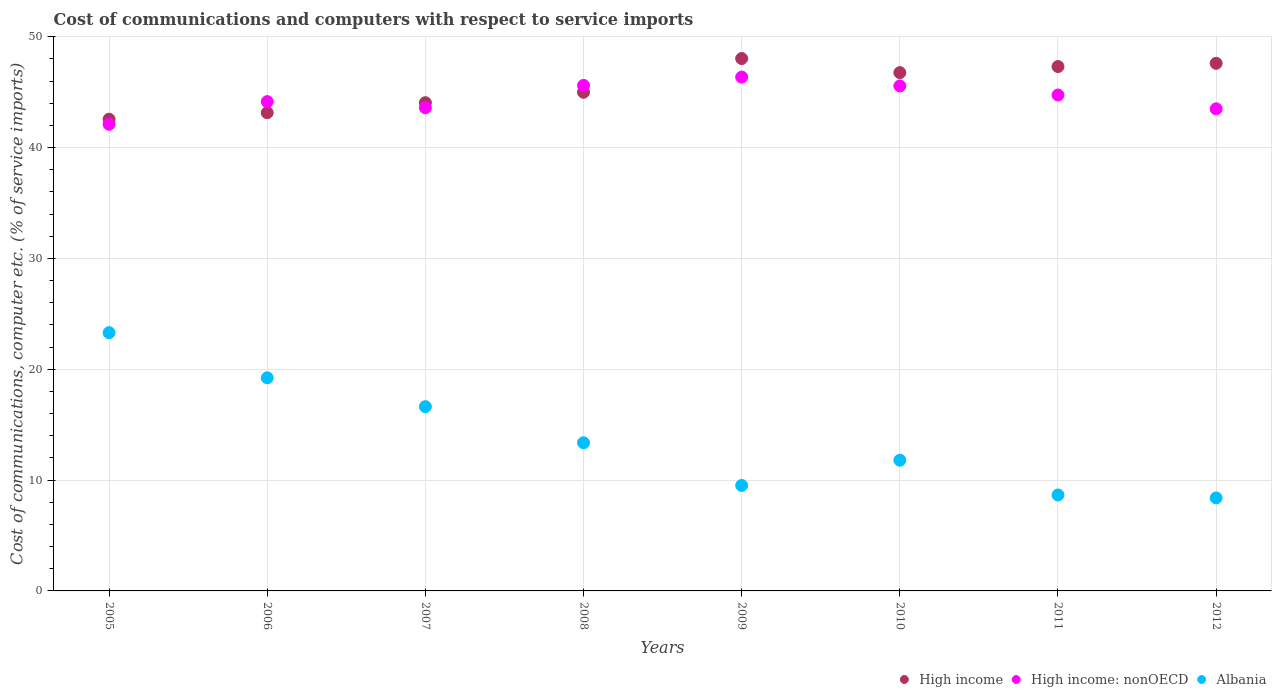What is the cost of communications and computers in High income in 2007?
Ensure brevity in your answer.  44.04. Across all years, what is the maximum cost of communications and computers in High income: nonOECD?
Provide a succinct answer. 46.35. Across all years, what is the minimum cost of communications and computers in Albania?
Your answer should be compact. 8.39. In which year was the cost of communications and computers in Albania maximum?
Make the answer very short. 2005. What is the total cost of communications and computers in High income: nonOECD in the graph?
Provide a succinct answer. 355.57. What is the difference between the cost of communications and computers in High income: nonOECD in 2011 and that in 2012?
Your response must be concise. 1.25. What is the difference between the cost of communications and computers in High income: nonOECD in 2005 and the cost of communications and computers in High income in 2008?
Your response must be concise. -2.89. What is the average cost of communications and computers in High income per year?
Provide a short and direct response. 45.55. In the year 2009, what is the difference between the cost of communications and computers in Albania and cost of communications and computers in High income?
Your answer should be very brief. -38.51. In how many years, is the cost of communications and computers in High income greater than 14 %?
Your response must be concise. 8. What is the ratio of the cost of communications and computers in Albania in 2006 to that in 2010?
Ensure brevity in your answer.  1.63. Is the difference between the cost of communications and computers in Albania in 2005 and 2008 greater than the difference between the cost of communications and computers in High income in 2005 and 2008?
Provide a succinct answer. Yes. What is the difference between the highest and the second highest cost of communications and computers in High income: nonOECD?
Offer a terse response. 0.75. What is the difference between the highest and the lowest cost of communications and computers in High income?
Your response must be concise. 5.47. How many years are there in the graph?
Keep it short and to the point. 8. What is the difference between two consecutive major ticks on the Y-axis?
Provide a succinct answer. 10. Are the values on the major ticks of Y-axis written in scientific E-notation?
Offer a very short reply. No. Where does the legend appear in the graph?
Your response must be concise. Bottom right. How many legend labels are there?
Offer a terse response. 3. What is the title of the graph?
Offer a very short reply. Cost of communications and computers with respect to service imports. What is the label or title of the X-axis?
Provide a succinct answer. Years. What is the label or title of the Y-axis?
Provide a short and direct response. Cost of communications, computer etc. (% of service imports). What is the Cost of communications, computer etc. (% of service imports) in High income in 2005?
Keep it short and to the point. 42.55. What is the Cost of communications, computer etc. (% of service imports) of High income: nonOECD in 2005?
Your answer should be compact. 42.1. What is the Cost of communications, computer etc. (% of service imports) in Albania in 2005?
Your response must be concise. 23.3. What is the Cost of communications, computer etc. (% of service imports) of High income in 2006?
Keep it short and to the point. 43.14. What is the Cost of communications, computer etc. (% of service imports) in High income: nonOECD in 2006?
Give a very brief answer. 44.14. What is the Cost of communications, computer etc. (% of service imports) in Albania in 2006?
Give a very brief answer. 19.23. What is the Cost of communications, computer etc. (% of service imports) in High income in 2007?
Keep it short and to the point. 44.04. What is the Cost of communications, computer etc. (% of service imports) of High income: nonOECD in 2007?
Your answer should be compact. 43.59. What is the Cost of communications, computer etc. (% of service imports) in Albania in 2007?
Make the answer very short. 16.62. What is the Cost of communications, computer etc. (% of service imports) of High income in 2008?
Your answer should be very brief. 44.98. What is the Cost of communications, computer etc. (% of service imports) in High income: nonOECD in 2008?
Ensure brevity in your answer.  45.61. What is the Cost of communications, computer etc. (% of service imports) in Albania in 2008?
Keep it short and to the point. 13.37. What is the Cost of communications, computer etc. (% of service imports) in High income in 2009?
Ensure brevity in your answer.  48.03. What is the Cost of communications, computer etc. (% of service imports) of High income: nonOECD in 2009?
Your answer should be very brief. 46.35. What is the Cost of communications, computer etc. (% of service imports) of Albania in 2009?
Your response must be concise. 9.52. What is the Cost of communications, computer etc. (% of service imports) in High income in 2010?
Your answer should be very brief. 46.76. What is the Cost of communications, computer etc. (% of service imports) in High income: nonOECD in 2010?
Your response must be concise. 45.55. What is the Cost of communications, computer etc. (% of service imports) of Albania in 2010?
Provide a succinct answer. 11.79. What is the Cost of communications, computer etc. (% of service imports) in High income in 2011?
Keep it short and to the point. 47.3. What is the Cost of communications, computer etc. (% of service imports) of High income: nonOECD in 2011?
Provide a short and direct response. 44.74. What is the Cost of communications, computer etc. (% of service imports) of Albania in 2011?
Offer a very short reply. 8.65. What is the Cost of communications, computer etc. (% of service imports) of High income in 2012?
Ensure brevity in your answer.  47.59. What is the Cost of communications, computer etc. (% of service imports) of High income: nonOECD in 2012?
Give a very brief answer. 43.49. What is the Cost of communications, computer etc. (% of service imports) in Albania in 2012?
Provide a succinct answer. 8.39. Across all years, what is the maximum Cost of communications, computer etc. (% of service imports) of High income?
Your response must be concise. 48.03. Across all years, what is the maximum Cost of communications, computer etc. (% of service imports) of High income: nonOECD?
Make the answer very short. 46.35. Across all years, what is the maximum Cost of communications, computer etc. (% of service imports) of Albania?
Provide a succinct answer. 23.3. Across all years, what is the minimum Cost of communications, computer etc. (% of service imports) of High income?
Provide a succinct answer. 42.55. Across all years, what is the minimum Cost of communications, computer etc. (% of service imports) in High income: nonOECD?
Your response must be concise. 42.1. Across all years, what is the minimum Cost of communications, computer etc. (% of service imports) of Albania?
Your response must be concise. 8.39. What is the total Cost of communications, computer etc. (% of service imports) in High income in the graph?
Offer a terse response. 364.4. What is the total Cost of communications, computer etc. (% of service imports) in High income: nonOECD in the graph?
Your answer should be compact. 355.57. What is the total Cost of communications, computer etc. (% of service imports) in Albania in the graph?
Provide a short and direct response. 110.87. What is the difference between the Cost of communications, computer etc. (% of service imports) in High income in 2005 and that in 2006?
Your response must be concise. -0.59. What is the difference between the Cost of communications, computer etc. (% of service imports) in High income: nonOECD in 2005 and that in 2006?
Provide a succinct answer. -2.04. What is the difference between the Cost of communications, computer etc. (% of service imports) of Albania in 2005 and that in 2006?
Provide a short and direct response. 4.07. What is the difference between the Cost of communications, computer etc. (% of service imports) in High income in 2005 and that in 2007?
Give a very brief answer. -1.49. What is the difference between the Cost of communications, computer etc. (% of service imports) in High income: nonOECD in 2005 and that in 2007?
Your answer should be compact. -1.49. What is the difference between the Cost of communications, computer etc. (% of service imports) of Albania in 2005 and that in 2007?
Offer a very short reply. 6.67. What is the difference between the Cost of communications, computer etc. (% of service imports) of High income in 2005 and that in 2008?
Ensure brevity in your answer.  -2.43. What is the difference between the Cost of communications, computer etc. (% of service imports) of High income: nonOECD in 2005 and that in 2008?
Your response must be concise. -3.51. What is the difference between the Cost of communications, computer etc. (% of service imports) in Albania in 2005 and that in 2008?
Keep it short and to the point. 9.93. What is the difference between the Cost of communications, computer etc. (% of service imports) of High income in 2005 and that in 2009?
Your response must be concise. -5.47. What is the difference between the Cost of communications, computer etc. (% of service imports) in High income: nonOECD in 2005 and that in 2009?
Your answer should be very brief. -4.26. What is the difference between the Cost of communications, computer etc. (% of service imports) in Albania in 2005 and that in 2009?
Your answer should be very brief. 13.78. What is the difference between the Cost of communications, computer etc. (% of service imports) in High income in 2005 and that in 2010?
Make the answer very short. -4.2. What is the difference between the Cost of communications, computer etc. (% of service imports) in High income: nonOECD in 2005 and that in 2010?
Give a very brief answer. -3.46. What is the difference between the Cost of communications, computer etc. (% of service imports) in Albania in 2005 and that in 2010?
Ensure brevity in your answer.  11.51. What is the difference between the Cost of communications, computer etc. (% of service imports) of High income in 2005 and that in 2011?
Your answer should be compact. -4.75. What is the difference between the Cost of communications, computer etc. (% of service imports) of High income: nonOECD in 2005 and that in 2011?
Your response must be concise. -2.64. What is the difference between the Cost of communications, computer etc. (% of service imports) of Albania in 2005 and that in 2011?
Provide a short and direct response. 14.64. What is the difference between the Cost of communications, computer etc. (% of service imports) of High income in 2005 and that in 2012?
Provide a short and direct response. -5.04. What is the difference between the Cost of communications, computer etc. (% of service imports) in High income: nonOECD in 2005 and that in 2012?
Your answer should be compact. -1.4. What is the difference between the Cost of communications, computer etc. (% of service imports) in Albania in 2005 and that in 2012?
Keep it short and to the point. 14.91. What is the difference between the Cost of communications, computer etc. (% of service imports) of High income in 2006 and that in 2007?
Your response must be concise. -0.9. What is the difference between the Cost of communications, computer etc. (% of service imports) of High income: nonOECD in 2006 and that in 2007?
Provide a short and direct response. 0.55. What is the difference between the Cost of communications, computer etc. (% of service imports) in Albania in 2006 and that in 2007?
Make the answer very short. 2.6. What is the difference between the Cost of communications, computer etc. (% of service imports) of High income in 2006 and that in 2008?
Ensure brevity in your answer.  -1.84. What is the difference between the Cost of communications, computer etc. (% of service imports) in High income: nonOECD in 2006 and that in 2008?
Provide a short and direct response. -1.47. What is the difference between the Cost of communications, computer etc. (% of service imports) in Albania in 2006 and that in 2008?
Make the answer very short. 5.86. What is the difference between the Cost of communications, computer etc. (% of service imports) of High income in 2006 and that in 2009?
Give a very brief answer. -4.89. What is the difference between the Cost of communications, computer etc. (% of service imports) in High income: nonOECD in 2006 and that in 2009?
Offer a terse response. -2.21. What is the difference between the Cost of communications, computer etc. (% of service imports) in Albania in 2006 and that in 2009?
Provide a short and direct response. 9.71. What is the difference between the Cost of communications, computer etc. (% of service imports) in High income in 2006 and that in 2010?
Keep it short and to the point. -3.62. What is the difference between the Cost of communications, computer etc. (% of service imports) of High income: nonOECD in 2006 and that in 2010?
Make the answer very short. -1.41. What is the difference between the Cost of communications, computer etc. (% of service imports) in Albania in 2006 and that in 2010?
Your response must be concise. 7.44. What is the difference between the Cost of communications, computer etc. (% of service imports) in High income in 2006 and that in 2011?
Your answer should be very brief. -4.16. What is the difference between the Cost of communications, computer etc. (% of service imports) in High income: nonOECD in 2006 and that in 2011?
Offer a very short reply. -0.6. What is the difference between the Cost of communications, computer etc. (% of service imports) in Albania in 2006 and that in 2011?
Ensure brevity in your answer.  10.57. What is the difference between the Cost of communications, computer etc. (% of service imports) of High income in 2006 and that in 2012?
Keep it short and to the point. -4.45. What is the difference between the Cost of communications, computer etc. (% of service imports) in High income: nonOECD in 2006 and that in 2012?
Give a very brief answer. 0.65. What is the difference between the Cost of communications, computer etc. (% of service imports) in Albania in 2006 and that in 2012?
Offer a terse response. 10.84. What is the difference between the Cost of communications, computer etc. (% of service imports) in High income in 2007 and that in 2008?
Provide a succinct answer. -0.94. What is the difference between the Cost of communications, computer etc. (% of service imports) of High income: nonOECD in 2007 and that in 2008?
Give a very brief answer. -2.02. What is the difference between the Cost of communications, computer etc. (% of service imports) of Albania in 2007 and that in 2008?
Provide a short and direct response. 3.26. What is the difference between the Cost of communications, computer etc. (% of service imports) of High income in 2007 and that in 2009?
Provide a succinct answer. -3.98. What is the difference between the Cost of communications, computer etc. (% of service imports) of High income: nonOECD in 2007 and that in 2009?
Give a very brief answer. -2.77. What is the difference between the Cost of communications, computer etc. (% of service imports) of Albania in 2007 and that in 2009?
Make the answer very short. 7.11. What is the difference between the Cost of communications, computer etc. (% of service imports) of High income in 2007 and that in 2010?
Offer a terse response. -2.71. What is the difference between the Cost of communications, computer etc. (% of service imports) of High income: nonOECD in 2007 and that in 2010?
Give a very brief answer. -1.97. What is the difference between the Cost of communications, computer etc. (% of service imports) of Albania in 2007 and that in 2010?
Keep it short and to the point. 4.84. What is the difference between the Cost of communications, computer etc. (% of service imports) of High income in 2007 and that in 2011?
Give a very brief answer. -3.26. What is the difference between the Cost of communications, computer etc. (% of service imports) of High income: nonOECD in 2007 and that in 2011?
Make the answer very short. -1.15. What is the difference between the Cost of communications, computer etc. (% of service imports) of Albania in 2007 and that in 2011?
Provide a succinct answer. 7.97. What is the difference between the Cost of communications, computer etc. (% of service imports) in High income in 2007 and that in 2012?
Ensure brevity in your answer.  -3.55. What is the difference between the Cost of communications, computer etc. (% of service imports) of High income: nonOECD in 2007 and that in 2012?
Make the answer very short. 0.09. What is the difference between the Cost of communications, computer etc. (% of service imports) of Albania in 2007 and that in 2012?
Make the answer very short. 8.23. What is the difference between the Cost of communications, computer etc. (% of service imports) in High income in 2008 and that in 2009?
Offer a very short reply. -3.04. What is the difference between the Cost of communications, computer etc. (% of service imports) of High income: nonOECD in 2008 and that in 2009?
Offer a very short reply. -0.75. What is the difference between the Cost of communications, computer etc. (% of service imports) of Albania in 2008 and that in 2009?
Your answer should be compact. 3.85. What is the difference between the Cost of communications, computer etc. (% of service imports) in High income in 2008 and that in 2010?
Keep it short and to the point. -1.77. What is the difference between the Cost of communications, computer etc. (% of service imports) in High income: nonOECD in 2008 and that in 2010?
Offer a very short reply. 0.05. What is the difference between the Cost of communications, computer etc. (% of service imports) of Albania in 2008 and that in 2010?
Your answer should be very brief. 1.58. What is the difference between the Cost of communications, computer etc. (% of service imports) of High income in 2008 and that in 2011?
Your response must be concise. -2.32. What is the difference between the Cost of communications, computer etc. (% of service imports) of High income: nonOECD in 2008 and that in 2011?
Provide a short and direct response. 0.87. What is the difference between the Cost of communications, computer etc. (% of service imports) of Albania in 2008 and that in 2011?
Give a very brief answer. 4.71. What is the difference between the Cost of communications, computer etc. (% of service imports) of High income in 2008 and that in 2012?
Give a very brief answer. -2.61. What is the difference between the Cost of communications, computer etc. (% of service imports) of High income: nonOECD in 2008 and that in 2012?
Your response must be concise. 2.11. What is the difference between the Cost of communications, computer etc. (% of service imports) in Albania in 2008 and that in 2012?
Your response must be concise. 4.97. What is the difference between the Cost of communications, computer etc. (% of service imports) in High income in 2009 and that in 2010?
Give a very brief answer. 1.27. What is the difference between the Cost of communications, computer etc. (% of service imports) of High income: nonOECD in 2009 and that in 2010?
Give a very brief answer. 0.8. What is the difference between the Cost of communications, computer etc. (% of service imports) in Albania in 2009 and that in 2010?
Offer a very short reply. -2.27. What is the difference between the Cost of communications, computer etc. (% of service imports) in High income in 2009 and that in 2011?
Give a very brief answer. 0.72. What is the difference between the Cost of communications, computer etc. (% of service imports) of High income: nonOECD in 2009 and that in 2011?
Give a very brief answer. 1.62. What is the difference between the Cost of communications, computer etc. (% of service imports) in Albania in 2009 and that in 2011?
Give a very brief answer. 0.86. What is the difference between the Cost of communications, computer etc. (% of service imports) in High income in 2009 and that in 2012?
Offer a very short reply. 0.43. What is the difference between the Cost of communications, computer etc. (% of service imports) in High income: nonOECD in 2009 and that in 2012?
Make the answer very short. 2.86. What is the difference between the Cost of communications, computer etc. (% of service imports) in Albania in 2009 and that in 2012?
Your answer should be compact. 1.12. What is the difference between the Cost of communications, computer etc. (% of service imports) in High income in 2010 and that in 2011?
Offer a very short reply. -0.55. What is the difference between the Cost of communications, computer etc. (% of service imports) in High income: nonOECD in 2010 and that in 2011?
Offer a terse response. 0.82. What is the difference between the Cost of communications, computer etc. (% of service imports) of Albania in 2010 and that in 2011?
Provide a succinct answer. 3.13. What is the difference between the Cost of communications, computer etc. (% of service imports) of High income in 2010 and that in 2012?
Ensure brevity in your answer.  -0.84. What is the difference between the Cost of communications, computer etc. (% of service imports) in High income: nonOECD in 2010 and that in 2012?
Your response must be concise. 2.06. What is the difference between the Cost of communications, computer etc. (% of service imports) in Albania in 2010 and that in 2012?
Give a very brief answer. 3.4. What is the difference between the Cost of communications, computer etc. (% of service imports) of High income in 2011 and that in 2012?
Keep it short and to the point. -0.29. What is the difference between the Cost of communications, computer etc. (% of service imports) of High income: nonOECD in 2011 and that in 2012?
Ensure brevity in your answer.  1.25. What is the difference between the Cost of communications, computer etc. (% of service imports) in Albania in 2011 and that in 2012?
Keep it short and to the point. 0.26. What is the difference between the Cost of communications, computer etc. (% of service imports) of High income in 2005 and the Cost of communications, computer etc. (% of service imports) of High income: nonOECD in 2006?
Provide a short and direct response. -1.59. What is the difference between the Cost of communications, computer etc. (% of service imports) in High income in 2005 and the Cost of communications, computer etc. (% of service imports) in Albania in 2006?
Make the answer very short. 23.33. What is the difference between the Cost of communications, computer etc. (% of service imports) in High income: nonOECD in 2005 and the Cost of communications, computer etc. (% of service imports) in Albania in 2006?
Your answer should be very brief. 22.87. What is the difference between the Cost of communications, computer etc. (% of service imports) in High income in 2005 and the Cost of communications, computer etc. (% of service imports) in High income: nonOECD in 2007?
Keep it short and to the point. -1.03. What is the difference between the Cost of communications, computer etc. (% of service imports) in High income in 2005 and the Cost of communications, computer etc. (% of service imports) in Albania in 2007?
Keep it short and to the point. 25.93. What is the difference between the Cost of communications, computer etc. (% of service imports) of High income: nonOECD in 2005 and the Cost of communications, computer etc. (% of service imports) of Albania in 2007?
Offer a very short reply. 25.47. What is the difference between the Cost of communications, computer etc. (% of service imports) in High income in 2005 and the Cost of communications, computer etc. (% of service imports) in High income: nonOECD in 2008?
Offer a very short reply. -3.05. What is the difference between the Cost of communications, computer etc. (% of service imports) of High income in 2005 and the Cost of communications, computer etc. (% of service imports) of Albania in 2008?
Your response must be concise. 29.19. What is the difference between the Cost of communications, computer etc. (% of service imports) in High income: nonOECD in 2005 and the Cost of communications, computer etc. (% of service imports) in Albania in 2008?
Make the answer very short. 28.73. What is the difference between the Cost of communications, computer etc. (% of service imports) in High income in 2005 and the Cost of communications, computer etc. (% of service imports) in High income: nonOECD in 2009?
Offer a terse response. -3.8. What is the difference between the Cost of communications, computer etc. (% of service imports) in High income in 2005 and the Cost of communications, computer etc. (% of service imports) in Albania in 2009?
Your answer should be very brief. 33.04. What is the difference between the Cost of communications, computer etc. (% of service imports) in High income: nonOECD in 2005 and the Cost of communications, computer etc. (% of service imports) in Albania in 2009?
Your response must be concise. 32.58. What is the difference between the Cost of communications, computer etc. (% of service imports) of High income in 2005 and the Cost of communications, computer etc. (% of service imports) of High income: nonOECD in 2010?
Make the answer very short. -3. What is the difference between the Cost of communications, computer etc. (% of service imports) in High income in 2005 and the Cost of communications, computer etc. (% of service imports) in Albania in 2010?
Your response must be concise. 30.77. What is the difference between the Cost of communications, computer etc. (% of service imports) in High income: nonOECD in 2005 and the Cost of communications, computer etc. (% of service imports) in Albania in 2010?
Provide a succinct answer. 30.31. What is the difference between the Cost of communications, computer etc. (% of service imports) of High income in 2005 and the Cost of communications, computer etc. (% of service imports) of High income: nonOECD in 2011?
Make the answer very short. -2.18. What is the difference between the Cost of communications, computer etc. (% of service imports) in High income in 2005 and the Cost of communications, computer etc. (% of service imports) in Albania in 2011?
Provide a short and direct response. 33.9. What is the difference between the Cost of communications, computer etc. (% of service imports) in High income: nonOECD in 2005 and the Cost of communications, computer etc. (% of service imports) in Albania in 2011?
Ensure brevity in your answer.  33.44. What is the difference between the Cost of communications, computer etc. (% of service imports) in High income in 2005 and the Cost of communications, computer etc. (% of service imports) in High income: nonOECD in 2012?
Make the answer very short. -0.94. What is the difference between the Cost of communications, computer etc. (% of service imports) of High income in 2005 and the Cost of communications, computer etc. (% of service imports) of Albania in 2012?
Ensure brevity in your answer.  34.16. What is the difference between the Cost of communications, computer etc. (% of service imports) in High income: nonOECD in 2005 and the Cost of communications, computer etc. (% of service imports) in Albania in 2012?
Provide a succinct answer. 33.7. What is the difference between the Cost of communications, computer etc. (% of service imports) of High income in 2006 and the Cost of communications, computer etc. (% of service imports) of High income: nonOECD in 2007?
Provide a short and direct response. -0.45. What is the difference between the Cost of communications, computer etc. (% of service imports) in High income in 2006 and the Cost of communications, computer etc. (% of service imports) in Albania in 2007?
Your response must be concise. 26.52. What is the difference between the Cost of communications, computer etc. (% of service imports) of High income: nonOECD in 2006 and the Cost of communications, computer etc. (% of service imports) of Albania in 2007?
Make the answer very short. 27.52. What is the difference between the Cost of communications, computer etc. (% of service imports) in High income in 2006 and the Cost of communications, computer etc. (% of service imports) in High income: nonOECD in 2008?
Make the answer very short. -2.46. What is the difference between the Cost of communications, computer etc. (% of service imports) of High income in 2006 and the Cost of communications, computer etc. (% of service imports) of Albania in 2008?
Make the answer very short. 29.77. What is the difference between the Cost of communications, computer etc. (% of service imports) of High income: nonOECD in 2006 and the Cost of communications, computer etc. (% of service imports) of Albania in 2008?
Your answer should be very brief. 30.77. What is the difference between the Cost of communications, computer etc. (% of service imports) in High income in 2006 and the Cost of communications, computer etc. (% of service imports) in High income: nonOECD in 2009?
Offer a very short reply. -3.21. What is the difference between the Cost of communications, computer etc. (% of service imports) of High income in 2006 and the Cost of communications, computer etc. (% of service imports) of Albania in 2009?
Offer a terse response. 33.62. What is the difference between the Cost of communications, computer etc. (% of service imports) in High income: nonOECD in 2006 and the Cost of communications, computer etc. (% of service imports) in Albania in 2009?
Provide a succinct answer. 34.62. What is the difference between the Cost of communications, computer etc. (% of service imports) in High income in 2006 and the Cost of communications, computer etc. (% of service imports) in High income: nonOECD in 2010?
Provide a succinct answer. -2.41. What is the difference between the Cost of communications, computer etc. (% of service imports) of High income in 2006 and the Cost of communications, computer etc. (% of service imports) of Albania in 2010?
Make the answer very short. 31.35. What is the difference between the Cost of communications, computer etc. (% of service imports) in High income: nonOECD in 2006 and the Cost of communications, computer etc. (% of service imports) in Albania in 2010?
Provide a succinct answer. 32.35. What is the difference between the Cost of communications, computer etc. (% of service imports) of High income in 2006 and the Cost of communications, computer etc. (% of service imports) of High income: nonOECD in 2011?
Make the answer very short. -1.6. What is the difference between the Cost of communications, computer etc. (% of service imports) of High income in 2006 and the Cost of communications, computer etc. (% of service imports) of Albania in 2011?
Keep it short and to the point. 34.49. What is the difference between the Cost of communications, computer etc. (% of service imports) of High income: nonOECD in 2006 and the Cost of communications, computer etc. (% of service imports) of Albania in 2011?
Keep it short and to the point. 35.49. What is the difference between the Cost of communications, computer etc. (% of service imports) in High income in 2006 and the Cost of communications, computer etc. (% of service imports) in High income: nonOECD in 2012?
Ensure brevity in your answer.  -0.35. What is the difference between the Cost of communications, computer etc. (% of service imports) in High income in 2006 and the Cost of communications, computer etc. (% of service imports) in Albania in 2012?
Ensure brevity in your answer.  34.75. What is the difference between the Cost of communications, computer etc. (% of service imports) of High income: nonOECD in 2006 and the Cost of communications, computer etc. (% of service imports) of Albania in 2012?
Provide a short and direct response. 35.75. What is the difference between the Cost of communications, computer etc. (% of service imports) of High income in 2007 and the Cost of communications, computer etc. (% of service imports) of High income: nonOECD in 2008?
Give a very brief answer. -1.56. What is the difference between the Cost of communications, computer etc. (% of service imports) of High income in 2007 and the Cost of communications, computer etc. (% of service imports) of Albania in 2008?
Ensure brevity in your answer.  30.68. What is the difference between the Cost of communications, computer etc. (% of service imports) of High income: nonOECD in 2007 and the Cost of communications, computer etc. (% of service imports) of Albania in 2008?
Make the answer very short. 30.22. What is the difference between the Cost of communications, computer etc. (% of service imports) in High income in 2007 and the Cost of communications, computer etc. (% of service imports) in High income: nonOECD in 2009?
Offer a very short reply. -2.31. What is the difference between the Cost of communications, computer etc. (% of service imports) of High income in 2007 and the Cost of communications, computer etc. (% of service imports) of Albania in 2009?
Your response must be concise. 34.53. What is the difference between the Cost of communications, computer etc. (% of service imports) in High income: nonOECD in 2007 and the Cost of communications, computer etc. (% of service imports) in Albania in 2009?
Your answer should be very brief. 34.07. What is the difference between the Cost of communications, computer etc. (% of service imports) of High income in 2007 and the Cost of communications, computer etc. (% of service imports) of High income: nonOECD in 2010?
Make the answer very short. -1.51. What is the difference between the Cost of communications, computer etc. (% of service imports) in High income in 2007 and the Cost of communications, computer etc. (% of service imports) in Albania in 2010?
Your response must be concise. 32.25. What is the difference between the Cost of communications, computer etc. (% of service imports) of High income: nonOECD in 2007 and the Cost of communications, computer etc. (% of service imports) of Albania in 2010?
Provide a short and direct response. 31.8. What is the difference between the Cost of communications, computer etc. (% of service imports) of High income in 2007 and the Cost of communications, computer etc. (% of service imports) of High income: nonOECD in 2011?
Offer a terse response. -0.69. What is the difference between the Cost of communications, computer etc. (% of service imports) of High income in 2007 and the Cost of communications, computer etc. (% of service imports) of Albania in 2011?
Offer a very short reply. 35.39. What is the difference between the Cost of communications, computer etc. (% of service imports) of High income: nonOECD in 2007 and the Cost of communications, computer etc. (% of service imports) of Albania in 2011?
Offer a very short reply. 34.93. What is the difference between the Cost of communications, computer etc. (% of service imports) of High income in 2007 and the Cost of communications, computer etc. (% of service imports) of High income: nonOECD in 2012?
Give a very brief answer. 0.55. What is the difference between the Cost of communications, computer etc. (% of service imports) in High income in 2007 and the Cost of communications, computer etc. (% of service imports) in Albania in 2012?
Provide a short and direct response. 35.65. What is the difference between the Cost of communications, computer etc. (% of service imports) in High income: nonOECD in 2007 and the Cost of communications, computer etc. (% of service imports) in Albania in 2012?
Ensure brevity in your answer.  35.2. What is the difference between the Cost of communications, computer etc. (% of service imports) of High income in 2008 and the Cost of communications, computer etc. (% of service imports) of High income: nonOECD in 2009?
Provide a succinct answer. -1.37. What is the difference between the Cost of communications, computer etc. (% of service imports) in High income in 2008 and the Cost of communications, computer etc. (% of service imports) in Albania in 2009?
Offer a terse response. 35.47. What is the difference between the Cost of communications, computer etc. (% of service imports) of High income: nonOECD in 2008 and the Cost of communications, computer etc. (% of service imports) of Albania in 2009?
Give a very brief answer. 36.09. What is the difference between the Cost of communications, computer etc. (% of service imports) of High income in 2008 and the Cost of communications, computer etc. (% of service imports) of High income: nonOECD in 2010?
Provide a succinct answer. -0.57. What is the difference between the Cost of communications, computer etc. (% of service imports) in High income in 2008 and the Cost of communications, computer etc. (% of service imports) in Albania in 2010?
Provide a succinct answer. 33.19. What is the difference between the Cost of communications, computer etc. (% of service imports) of High income: nonOECD in 2008 and the Cost of communications, computer etc. (% of service imports) of Albania in 2010?
Provide a succinct answer. 33.82. What is the difference between the Cost of communications, computer etc. (% of service imports) in High income in 2008 and the Cost of communications, computer etc. (% of service imports) in High income: nonOECD in 2011?
Your answer should be compact. 0.24. What is the difference between the Cost of communications, computer etc. (% of service imports) of High income in 2008 and the Cost of communications, computer etc. (% of service imports) of Albania in 2011?
Offer a terse response. 36.33. What is the difference between the Cost of communications, computer etc. (% of service imports) in High income: nonOECD in 2008 and the Cost of communications, computer etc. (% of service imports) in Albania in 2011?
Ensure brevity in your answer.  36.95. What is the difference between the Cost of communications, computer etc. (% of service imports) in High income in 2008 and the Cost of communications, computer etc. (% of service imports) in High income: nonOECD in 2012?
Ensure brevity in your answer.  1.49. What is the difference between the Cost of communications, computer etc. (% of service imports) of High income in 2008 and the Cost of communications, computer etc. (% of service imports) of Albania in 2012?
Your answer should be compact. 36.59. What is the difference between the Cost of communications, computer etc. (% of service imports) of High income: nonOECD in 2008 and the Cost of communications, computer etc. (% of service imports) of Albania in 2012?
Make the answer very short. 37.21. What is the difference between the Cost of communications, computer etc. (% of service imports) in High income in 2009 and the Cost of communications, computer etc. (% of service imports) in High income: nonOECD in 2010?
Keep it short and to the point. 2.47. What is the difference between the Cost of communications, computer etc. (% of service imports) of High income in 2009 and the Cost of communications, computer etc. (% of service imports) of Albania in 2010?
Provide a short and direct response. 36.24. What is the difference between the Cost of communications, computer etc. (% of service imports) in High income: nonOECD in 2009 and the Cost of communications, computer etc. (% of service imports) in Albania in 2010?
Provide a succinct answer. 34.57. What is the difference between the Cost of communications, computer etc. (% of service imports) in High income in 2009 and the Cost of communications, computer etc. (% of service imports) in High income: nonOECD in 2011?
Keep it short and to the point. 3.29. What is the difference between the Cost of communications, computer etc. (% of service imports) in High income in 2009 and the Cost of communications, computer etc. (% of service imports) in Albania in 2011?
Your answer should be very brief. 39.37. What is the difference between the Cost of communications, computer etc. (% of service imports) of High income: nonOECD in 2009 and the Cost of communications, computer etc. (% of service imports) of Albania in 2011?
Offer a very short reply. 37.7. What is the difference between the Cost of communications, computer etc. (% of service imports) in High income in 2009 and the Cost of communications, computer etc. (% of service imports) in High income: nonOECD in 2012?
Offer a very short reply. 4.53. What is the difference between the Cost of communications, computer etc. (% of service imports) in High income in 2009 and the Cost of communications, computer etc. (% of service imports) in Albania in 2012?
Provide a short and direct response. 39.64. What is the difference between the Cost of communications, computer etc. (% of service imports) of High income: nonOECD in 2009 and the Cost of communications, computer etc. (% of service imports) of Albania in 2012?
Give a very brief answer. 37.96. What is the difference between the Cost of communications, computer etc. (% of service imports) in High income in 2010 and the Cost of communications, computer etc. (% of service imports) in High income: nonOECD in 2011?
Provide a succinct answer. 2.02. What is the difference between the Cost of communications, computer etc. (% of service imports) of High income in 2010 and the Cost of communications, computer etc. (% of service imports) of Albania in 2011?
Provide a succinct answer. 38.1. What is the difference between the Cost of communications, computer etc. (% of service imports) of High income: nonOECD in 2010 and the Cost of communications, computer etc. (% of service imports) of Albania in 2011?
Provide a short and direct response. 36.9. What is the difference between the Cost of communications, computer etc. (% of service imports) of High income in 2010 and the Cost of communications, computer etc. (% of service imports) of High income: nonOECD in 2012?
Your answer should be compact. 3.26. What is the difference between the Cost of communications, computer etc. (% of service imports) in High income in 2010 and the Cost of communications, computer etc. (% of service imports) in Albania in 2012?
Your response must be concise. 38.37. What is the difference between the Cost of communications, computer etc. (% of service imports) in High income: nonOECD in 2010 and the Cost of communications, computer etc. (% of service imports) in Albania in 2012?
Your response must be concise. 37.16. What is the difference between the Cost of communications, computer etc. (% of service imports) in High income in 2011 and the Cost of communications, computer etc. (% of service imports) in High income: nonOECD in 2012?
Offer a terse response. 3.81. What is the difference between the Cost of communications, computer etc. (% of service imports) in High income in 2011 and the Cost of communications, computer etc. (% of service imports) in Albania in 2012?
Make the answer very short. 38.91. What is the difference between the Cost of communications, computer etc. (% of service imports) of High income: nonOECD in 2011 and the Cost of communications, computer etc. (% of service imports) of Albania in 2012?
Offer a very short reply. 36.35. What is the average Cost of communications, computer etc. (% of service imports) in High income per year?
Provide a short and direct response. 45.55. What is the average Cost of communications, computer etc. (% of service imports) of High income: nonOECD per year?
Your answer should be compact. 44.45. What is the average Cost of communications, computer etc. (% of service imports) of Albania per year?
Offer a terse response. 13.86. In the year 2005, what is the difference between the Cost of communications, computer etc. (% of service imports) in High income and Cost of communications, computer etc. (% of service imports) in High income: nonOECD?
Give a very brief answer. 0.46. In the year 2005, what is the difference between the Cost of communications, computer etc. (% of service imports) in High income and Cost of communications, computer etc. (% of service imports) in Albania?
Provide a succinct answer. 19.26. In the year 2005, what is the difference between the Cost of communications, computer etc. (% of service imports) of High income: nonOECD and Cost of communications, computer etc. (% of service imports) of Albania?
Offer a terse response. 18.8. In the year 2006, what is the difference between the Cost of communications, computer etc. (% of service imports) of High income and Cost of communications, computer etc. (% of service imports) of High income: nonOECD?
Your answer should be very brief. -1. In the year 2006, what is the difference between the Cost of communications, computer etc. (% of service imports) in High income and Cost of communications, computer etc. (% of service imports) in Albania?
Keep it short and to the point. 23.91. In the year 2006, what is the difference between the Cost of communications, computer etc. (% of service imports) in High income: nonOECD and Cost of communications, computer etc. (% of service imports) in Albania?
Keep it short and to the point. 24.91. In the year 2007, what is the difference between the Cost of communications, computer etc. (% of service imports) in High income and Cost of communications, computer etc. (% of service imports) in High income: nonOECD?
Make the answer very short. 0.46. In the year 2007, what is the difference between the Cost of communications, computer etc. (% of service imports) of High income and Cost of communications, computer etc. (% of service imports) of Albania?
Your answer should be compact. 27.42. In the year 2007, what is the difference between the Cost of communications, computer etc. (% of service imports) in High income: nonOECD and Cost of communications, computer etc. (% of service imports) in Albania?
Offer a very short reply. 26.96. In the year 2008, what is the difference between the Cost of communications, computer etc. (% of service imports) in High income and Cost of communications, computer etc. (% of service imports) in High income: nonOECD?
Give a very brief answer. -0.62. In the year 2008, what is the difference between the Cost of communications, computer etc. (% of service imports) of High income and Cost of communications, computer etc. (% of service imports) of Albania?
Offer a very short reply. 31.62. In the year 2008, what is the difference between the Cost of communications, computer etc. (% of service imports) in High income: nonOECD and Cost of communications, computer etc. (% of service imports) in Albania?
Provide a short and direct response. 32.24. In the year 2009, what is the difference between the Cost of communications, computer etc. (% of service imports) of High income and Cost of communications, computer etc. (% of service imports) of High income: nonOECD?
Offer a terse response. 1.67. In the year 2009, what is the difference between the Cost of communications, computer etc. (% of service imports) in High income and Cost of communications, computer etc. (% of service imports) in Albania?
Your response must be concise. 38.51. In the year 2009, what is the difference between the Cost of communications, computer etc. (% of service imports) of High income: nonOECD and Cost of communications, computer etc. (% of service imports) of Albania?
Offer a very short reply. 36.84. In the year 2010, what is the difference between the Cost of communications, computer etc. (% of service imports) in High income and Cost of communications, computer etc. (% of service imports) in High income: nonOECD?
Ensure brevity in your answer.  1.2. In the year 2010, what is the difference between the Cost of communications, computer etc. (% of service imports) in High income and Cost of communications, computer etc. (% of service imports) in Albania?
Provide a short and direct response. 34.97. In the year 2010, what is the difference between the Cost of communications, computer etc. (% of service imports) of High income: nonOECD and Cost of communications, computer etc. (% of service imports) of Albania?
Your answer should be compact. 33.77. In the year 2011, what is the difference between the Cost of communications, computer etc. (% of service imports) of High income and Cost of communications, computer etc. (% of service imports) of High income: nonOECD?
Give a very brief answer. 2.57. In the year 2011, what is the difference between the Cost of communications, computer etc. (% of service imports) in High income and Cost of communications, computer etc. (% of service imports) in Albania?
Your answer should be very brief. 38.65. In the year 2011, what is the difference between the Cost of communications, computer etc. (% of service imports) of High income: nonOECD and Cost of communications, computer etc. (% of service imports) of Albania?
Your response must be concise. 36.08. In the year 2012, what is the difference between the Cost of communications, computer etc. (% of service imports) of High income and Cost of communications, computer etc. (% of service imports) of High income: nonOECD?
Keep it short and to the point. 4.1. In the year 2012, what is the difference between the Cost of communications, computer etc. (% of service imports) of High income and Cost of communications, computer etc. (% of service imports) of Albania?
Offer a terse response. 39.2. In the year 2012, what is the difference between the Cost of communications, computer etc. (% of service imports) in High income: nonOECD and Cost of communications, computer etc. (% of service imports) in Albania?
Your response must be concise. 35.1. What is the ratio of the Cost of communications, computer etc. (% of service imports) of High income in 2005 to that in 2006?
Your answer should be compact. 0.99. What is the ratio of the Cost of communications, computer etc. (% of service imports) in High income: nonOECD in 2005 to that in 2006?
Your response must be concise. 0.95. What is the ratio of the Cost of communications, computer etc. (% of service imports) of Albania in 2005 to that in 2006?
Your response must be concise. 1.21. What is the ratio of the Cost of communications, computer etc. (% of service imports) in High income in 2005 to that in 2007?
Your response must be concise. 0.97. What is the ratio of the Cost of communications, computer etc. (% of service imports) in High income: nonOECD in 2005 to that in 2007?
Provide a short and direct response. 0.97. What is the ratio of the Cost of communications, computer etc. (% of service imports) in Albania in 2005 to that in 2007?
Ensure brevity in your answer.  1.4. What is the ratio of the Cost of communications, computer etc. (% of service imports) of High income in 2005 to that in 2008?
Ensure brevity in your answer.  0.95. What is the ratio of the Cost of communications, computer etc. (% of service imports) in High income: nonOECD in 2005 to that in 2008?
Provide a succinct answer. 0.92. What is the ratio of the Cost of communications, computer etc. (% of service imports) of Albania in 2005 to that in 2008?
Provide a short and direct response. 1.74. What is the ratio of the Cost of communications, computer etc. (% of service imports) of High income in 2005 to that in 2009?
Keep it short and to the point. 0.89. What is the ratio of the Cost of communications, computer etc. (% of service imports) in High income: nonOECD in 2005 to that in 2009?
Offer a very short reply. 0.91. What is the ratio of the Cost of communications, computer etc. (% of service imports) in Albania in 2005 to that in 2009?
Offer a very short reply. 2.45. What is the ratio of the Cost of communications, computer etc. (% of service imports) of High income in 2005 to that in 2010?
Keep it short and to the point. 0.91. What is the ratio of the Cost of communications, computer etc. (% of service imports) of High income: nonOECD in 2005 to that in 2010?
Offer a terse response. 0.92. What is the ratio of the Cost of communications, computer etc. (% of service imports) of Albania in 2005 to that in 2010?
Give a very brief answer. 1.98. What is the ratio of the Cost of communications, computer etc. (% of service imports) in High income in 2005 to that in 2011?
Your response must be concise. 0.9. What is the ratio of the Cost of communications, computer etc. (% of service imports) of High income: nonOECD in 2005 to that in 2011?
Keep it short and to the point. 0.94. What is the ratio of the Cost of communications, computer etc. (% of service imports) of Albania in 2005 to that in 2011?
Give a very brief answer. 2.69. What is the ratio of the Cost of communications, computer etc. (% of service imports) of High income in 2005 to that in 2012?
Provide a short and direct response. 0.89. What is the ratio of the Cost of communications, computer etc. (% of service imports) of High income: nonOECD in 2005 to that in 2012?
Give a very brief answer. 0.97. What is the ratio of the Cost of communications, computer etc. (% of service imports) in Albania in 2005 to that in 2012?
Offer a very short reply. 2.78. What is the ratio of the Cost of communications, computer etc. (% of service imports) of High income in 2006 to that in 2007?
Give a very brief answer. 0.98. What is the ratio of the Cost of communications, computer etc. (% of service imports) of High income: nonOECD in 2006 to that in 2007?
Offer a very short reply. 1.01. What is the ratio of the Cost of communications, computer etc. (% of service imports) in Albania in 2006 to that in 2007?
Keep it short and to the point. 1.16. What is the ratio of the Cost of communications, computer etc. (% of service imports) in High income: nonOECD in 2006 to that in 2008?
Give a very brief answer. 0.97. What is the ratio of the Cost of communications, computer etc. (% of service imports) in Albania in 2006 to that in 2008?
Ensure brevity in your answer.  1.44. What is the ratio of the Cost of communications, computer etc. (% of service imports) of High income in 2006 to that in 2009?
Keep it short and to the point. 0.9. What is the ratio of the Cost of communications, computer etc. (% of service imports) in High income: nonOECD in 2006 to that in 2009?
Ensure brevity in your answer.  0.95. What is the ratio of the Cost of communications, computer etc. (% of service imports) in Albania in 2006 to that in 2009?
Make the answer very short. 2.02. What is the ratio of the Cost of communications, computer etc. (% of service imports) of High income in 2006 to that in 2010?
Give a very brief answer. 0.92. What is the ratio of the Cost of communications, computer etc. (% of service imports) of Albania in 2006 to that in 2010?
Your answer should be compact. 1.63. What is the ratio of the Cost of communications, computer etc. (% of service imports) of High income in 2006 to that in 2011?
Your answer should be compact. 0.91. What is the ratio of the Cost of communications, computer etc. (% of service imports) of High income: nonOECD in 2006 to that in 2011?
Keep it short and to the point. 0.99. What is the ratio of the Cost of communications, computer etc. (% of service imports) of Albania in 2006 to that in 2011?
Your answer should be compact. 2.22. What is the ratio of the Cost of communications, computer etc. (% of service imports) of High income in 2006 to that in 2012?
Provide a short and direct response. 0.91. What is the ratio of the Cost of communications, computer etc. (% of service imports) of High income: nonOECD in 2006 to that in 2012?
Keep it short and to the point. 1.01. What is the ratio of the Cost of communications, computer etc. (% of service imports) in Albania in 2006 to that in 2012?
Ensure brevity in your answer.  2.29. What is the ratio of the Cost of communications, computer etc. (% of service imports) in High income in 2007 to that in 2008?
Offer a very short reply. 0.98. What is the ratio of the Cost of communications, computer etc. (% of service imports) in High income: nonOECD in 2007 to that in 2008?
Provide a short and direct response. 0.96. What is the ratio of the Cost of communications, computer etc. (% of service imports) in Albania in 2007 to that in 2008?
Ensure brevity in your answer.  1.24. What is the ratio of the Cost of communications, computer etc. (% of service imports) of High income in 2007 to that in 2009?
Your response must be concise. 0.92. What is the ratio of the Cost of communications, computer etc. (% of service imports) in High income: nonOECD in 2007 to that in 2009?
Your response must be concise. 0.94. What is the ratio of the Cost of communications, computer etc. (% of service imports) of Albania in 2007 to that in 2009?
Provide a succinct answer. 1.75. What is the ratio of the Cost of communications, computer etc. (% of service imports) in High income in 2007 to that in 2010?
Your answer should be very brief. 0.94. What is the ratio of the Cost of communications, computer etc. (% of service imports) in High income: nonOECD in 2007 to that in 2010?
Your response must be concise. 0.96. What is the ratio of the Cost of communications, computer etc. (% of service imports) of Albania in 2007 to that in 2010?
Offer a terse response. 1.41. What is the ratio of the Cost of communications, computer etc. (% of service imports) in High income in 2007 to that in 2011?
Give a very brief answer. 0.93. What is the ratio of the Cost of communications, computer etc. (% of service imports) of High income: nonOECD in 2007 to that in 2011?
Your answer should be compact. 0.97. What is the ratio of the Cost of communications, computer etc. (% of service imports) in Albania in 2007 to that in 2011?
Your answer should be very brief. 1.92. What is the ratio of the Cost of communications, computer etc. (% of service imports) of High income in 2007 to that in 2012?
Offer a very short reply. 0.93. What is the ratio of the Cost of communications, computer etc. (% of service imports) in Albania in 2007 to that in 2012?
Your answer should be compact. 1.98. What is the ratio of the Cost of communications, computer etc. (% of service imports) of High income in 2008 to that in 2009?
Keep it short and to the point. 0.94. What is the ratio of the Cost of communications, computer etc. (% of service imports) in High income: nonOECD in 2008 to that in 2009?
Offer a terse response. 0.98. What is the ratio of the Cost of communications, computer etc. (% of service imports) of Albania in 2008 to that in 2009?
Give a very brief answer. 1.4. What is the ratio of the Cost of communications, computer etc. (% of service imports) of High income in 2008 to that in 2010?
Your answer should be very brief. 0.96. What is the ratio of the Cost of communications, computer etc. (% of service imports) in Albania in 2008 to that in 2010?
Give a very brief answer. 1.13. What is the ratio of the Cost of communications, computer etc. (% of service imports) of High income in 2008 to that in 2011?
Your response must be concise. 0.95. What is the ratio of the Cost of communications, computer etc. (% of service imports) of High income: nonOECD in 2008 to that in 2011?
Your answer should be very brief. 1.02. What is the ratio of the Cost of communications, computer etc. (% of service imports) in Albania in 2008 to that in 2011?
Ensure brevity in your answer.  1.54. What is the ratio of the Cost of communications, computer etc. (% of service imports) in High income in 2008 to that in 2012?
Provide a short and direct response. 0.95. What is the ratio of the Cost of communications, computer etc. (% of service imports) of High income: nonOECD in 2008 to that in 2012?
Your response must be concise. 1.05. What is the ratio of the Cost of communications, computer etc. (% of service imports) of Albania in 2008 to that in 2012?
Offer a very short reply. 1.59. What is the ratio of the Cost of communications, computer etc. (% of service imports) in High income in 2009 to that in 2010?
Offer a terse response. 1.03. What is the ratio of the Cost of communications, computer etc. (% of service imports) in High income: nonOECD in 2009 to that in 2010?
Keep it short and to the point. 1.02. What is the ratio of the Cost of communications, computer etc. (% of service imports) of Albania in 2009 to that in 2010?
Make the answer very short. 0.81. What is the ratio of the Cost of communications, computer etc. (% of service imports) of High income in 2009 to that in 2011?
Provide a short and direct response. 1.02. What is the ratio of the Cost of communications, computer etc. (% of service imports) of High income: nonOECD in 2009 to that in 2011?
Keep it short and to the point. 1.04. What is the ratio of the Cost of communications, computer etc. (% of service imports) of Albania in 2009 to that in 2011?
Make the answer very short. 1.1. What is the ratio of the Cost of communications, computer etc. (% of service imports) in High income in 2009 to that in 2012?
Your answer should be very brief. 1.01. What is the ratio of the Cost of communications, computer etc. (% of service imports) of High income: nonOECD in 2009 to that in 2012?
Give a very brief answer. 1.07. What is the ratio of the Cost of communications, computer etc. (% of service imports) in Albania in 2009 to that in 2012?
Give a very brief answer. 1.13. What is the ratio of the Cost of communications, computer etc. (% of service imports) of High income in 2010 to that in 2011?
Provide a succinct answer. 0.99. What is the ratio of the Cost of communications, computer etc. (% of service imports) of High income: nonOECD in 2010 to that in 2011?
Your answer should be compact. 1.02. What is the ratio of the Cost of communications, computer etc. (% of service imports) of Albania in 2010 to that in 2011?
Offer a very short reply. 1.36. What is the ratio of the Cost of communications, computer etc. (% of service imports) in High income in 2010 to that in 2012?
Give a very brief answer. 0.98. What is the ratio of the Cost of communications, computer etc. (% of service imports) in High income: nonOECD in 2010 to that in 2012?
Offer a terse response. 1.05. What is the ratio of the Cost of communications, computer etc. (% of service imports) of Albania in 2010 to that in 2012?
Give a very brief answer. 1.4. What is the ratio of the Cost of communications, computer etc. (% of service imports) in High income: nonOECD in 2011 to that in 2012?
Offer a terse response. 1.03. What is the ratio of the Cost of communications, computer etc. (% of service imports) in Albania in 2011 to that in 2012?
Provide a succinct answer. 1.03. What is the difference between the highest and the second highest Cost of communications, computer etc. (% of service imports) in High income?
Your answer should be very brief. 0.43. What is the difference between the highest and the second highest Cost of communications, computer etc. (% of service imports) of High income: nonOECD?
Give a very brief answer. 0.75. What is the difference between the highest and the second highest Cost of communications, computer etc. (% of service imports) of Albania?
Your response must be concise. 4.07. What is the difference between the highest and the lowest Cost of communications, computer etc. (% of service imports) in High income?
Give a very brief answer. 5.47. What is the difference between the highest and the lowest Cost of communications, computer etc. (% of service imports) in High income: nonOECD?
Offer a very short reply. 4.26. What is the difference between the highest and the lowest Cost of communications, computer etc. (% of service imports) in Albania?
Your answer should be compact. 14.91. 